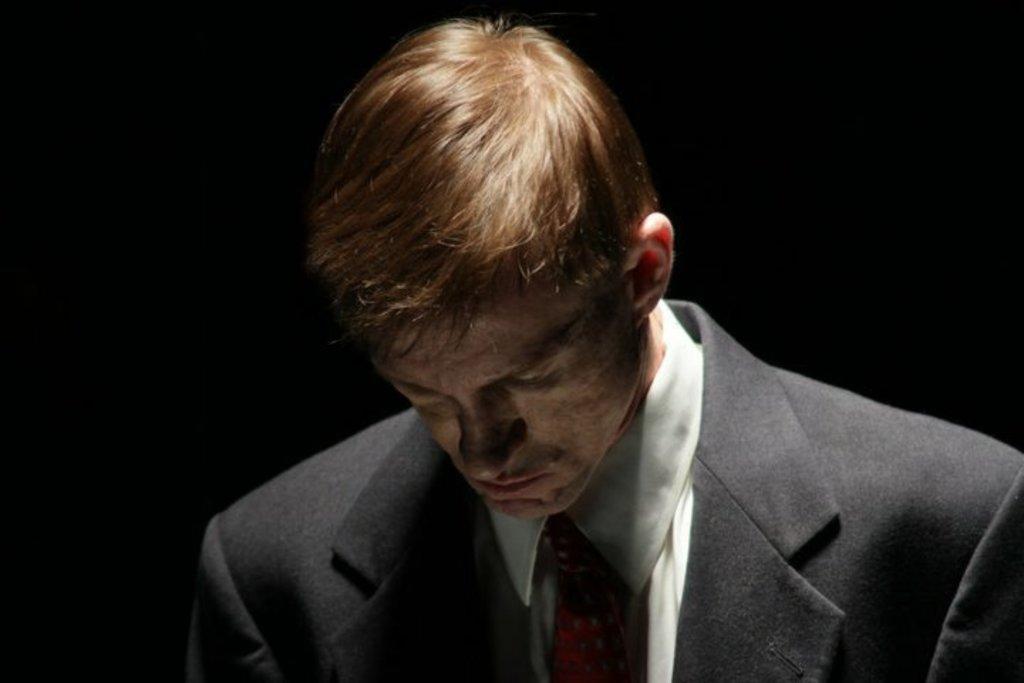Please provide a concise description of this image. In this image we can see a person. 